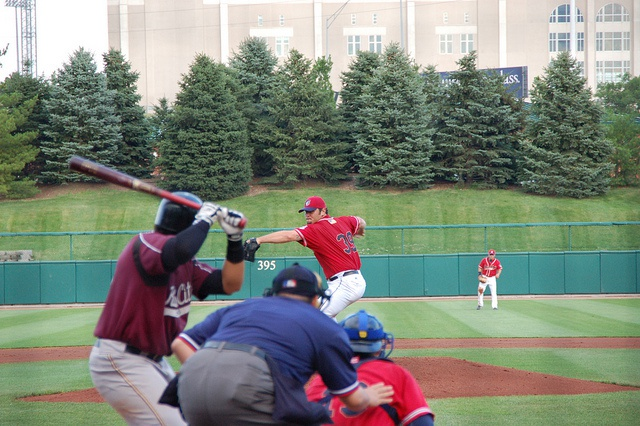Describe the objects in this image and their specific colors. I can see people in white, black, maroon, darkgray, and purple tones, people in white, blue, navy, black, and gray tones, people in white, brown, navy, and black tones, people in white, lavender, and brown tones, and baseball bat in white, darkgray, black, maroon, and gray tones in this image. 